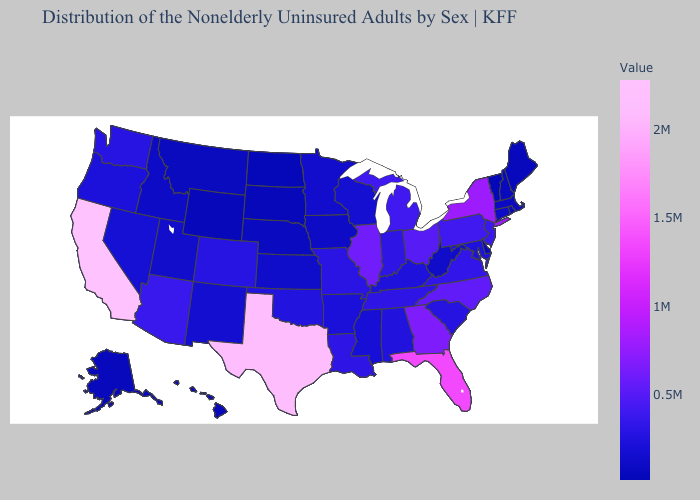Among the states that border Florida , which have the highest value?
Be succinct. Georgia. Does Ohio have the highest value in the USA?
Keep it brief. No. Which states have the lowest value in the USA?
Be succinct. North Dakota. Which states hav the highest value in the MidWest?
Give a very brief answer. Illinois. Which states have the highest value in the USA?
Keep it brief. California. Does the map have missing data?
Short answer required. No. Which states have the lowest value in the Northeast?
Write a very short answer. Vermont. Which states have the highest value in the USA?
Concise answer only. California. 